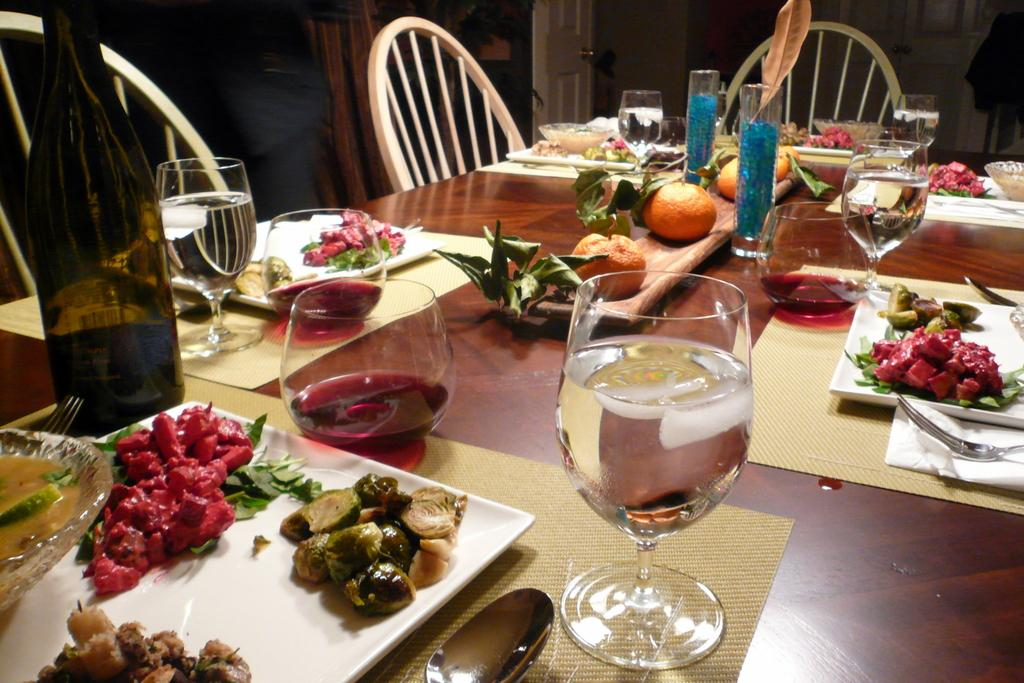What type of furniture is present in the image? There is a table in the image. What is on the table? The table has a place setting, food, a wine bottle, wine glasses, a water bottle, and fruits. What might be used for drinking in the image? There are wine glasses and a water bottle on the table. What type of beverage is present in the image? There is a wine bottle on the table. Where is the ship docked in the image? There is no ship present in the image; it only features a table with various items. 